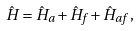Convert formula to latex. <formula><loc_0><loc_0><loc_500><loc_500>\hat { H } = \hat { H } _ { a } + \hat { H } _ { f } + \hat { H } _ { a f } \, ,</formula> 